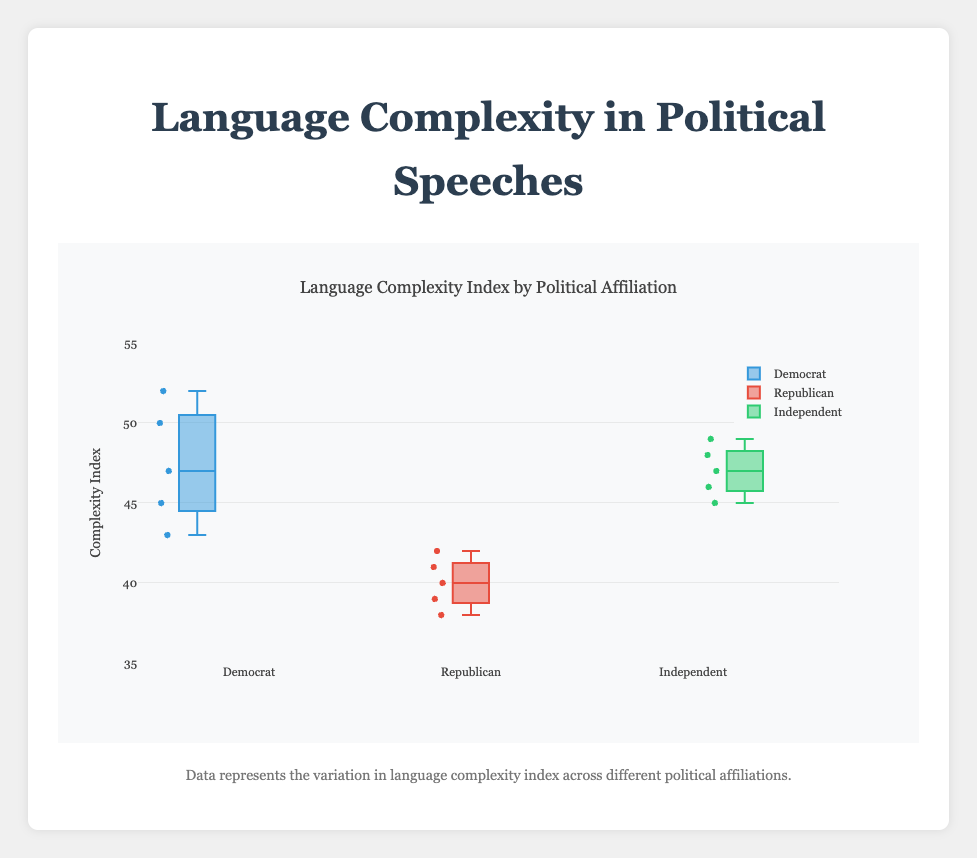What is the title of the figure? The title is shown at the top of the figure and is typical in most plots.
Answer: Language Complexity Index by Political Affiliation What is the range of the y-axis? The y-axis range is labeled on the left side of the plot and is specified from 35 to 55.
Answer: 35 to 55 How many data points are in the Democrat group? To find the number of data points, count the individual markers inside the Democrat box plot. There are 5 data points.
Answer: 5 Which political affiliation group has the widest range of complexity indices? To determine the widest range, compare the length of the boxes (interquartile range) for each group. The Democrat group ranges from 43 to 52, which is wider than the ranges of Republicans (38-42) and Independents (45-49).
Answer: Democrat What is the median complexity index for the Republican group? The median is represented by the line inside the box. For Republicans, this median line is at 40.
Answer: 40 Which political affiliation group has the highest maximum complexity index? The highest maximum complexity index is the top end of the whisker line for each box plot. The Democrat group has the highest maximum complexity index at 52.
Answer: Democrat What is the difference between the median complexity indices of Democrats and Independents? The median complexity indices for Democrats and Independents can be found as the lines inside their respective boxes. Democrats have a median at 47, and Independents at 47. The difference is 0.
Answer: 0 Which political affiliation group has the smallest interquartile range (IQR)? The IQR is the distance between the first and third quartiles (bottom and top edges of the box). For Republicans, the range is from 39 to 42 (IQR = 3), which is smaller than Democrats (43-50, IQR = 7) and Independents (45-48, IQR = 3). Since there’s a tie, specify by verifying the actual expansion of the IQR visually in the plot.
Answer: Tie between Republican and Independent What is the color representation for Independents in the plot? The colors used for each group are visually distinguishable. Independents are represented by a green color.
Answer: Green 